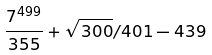Convert formula to latex. <formula><loc_0><loc_0><loc_500><loc_500>\frac { 7 ^ { 4 9 9 } } { 3 5 5 } + \sqrt { 3 0 0 } / 4 0 1 - 4 3 9</formula> 